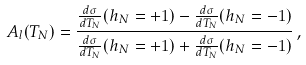Convert formula to latex. <formula><loc_0><loc_0><loc_500><loc_500>A _ { l } ( T _ { N } ) = \frac { \frac { d \sigma } { d T _ { N } } ( h _ { N } = + 1 ) - \frac { d \sigma } { d T _ { N } } ( h _ { N } = - 1 ) } { \frac { d \sigma } { d T _ { N } } ( h _ { N } = + 1 ) + \frac { d \sigma } { d T _ { N } } ( h _ { N } = - 1 ) } \, ,</formula> 